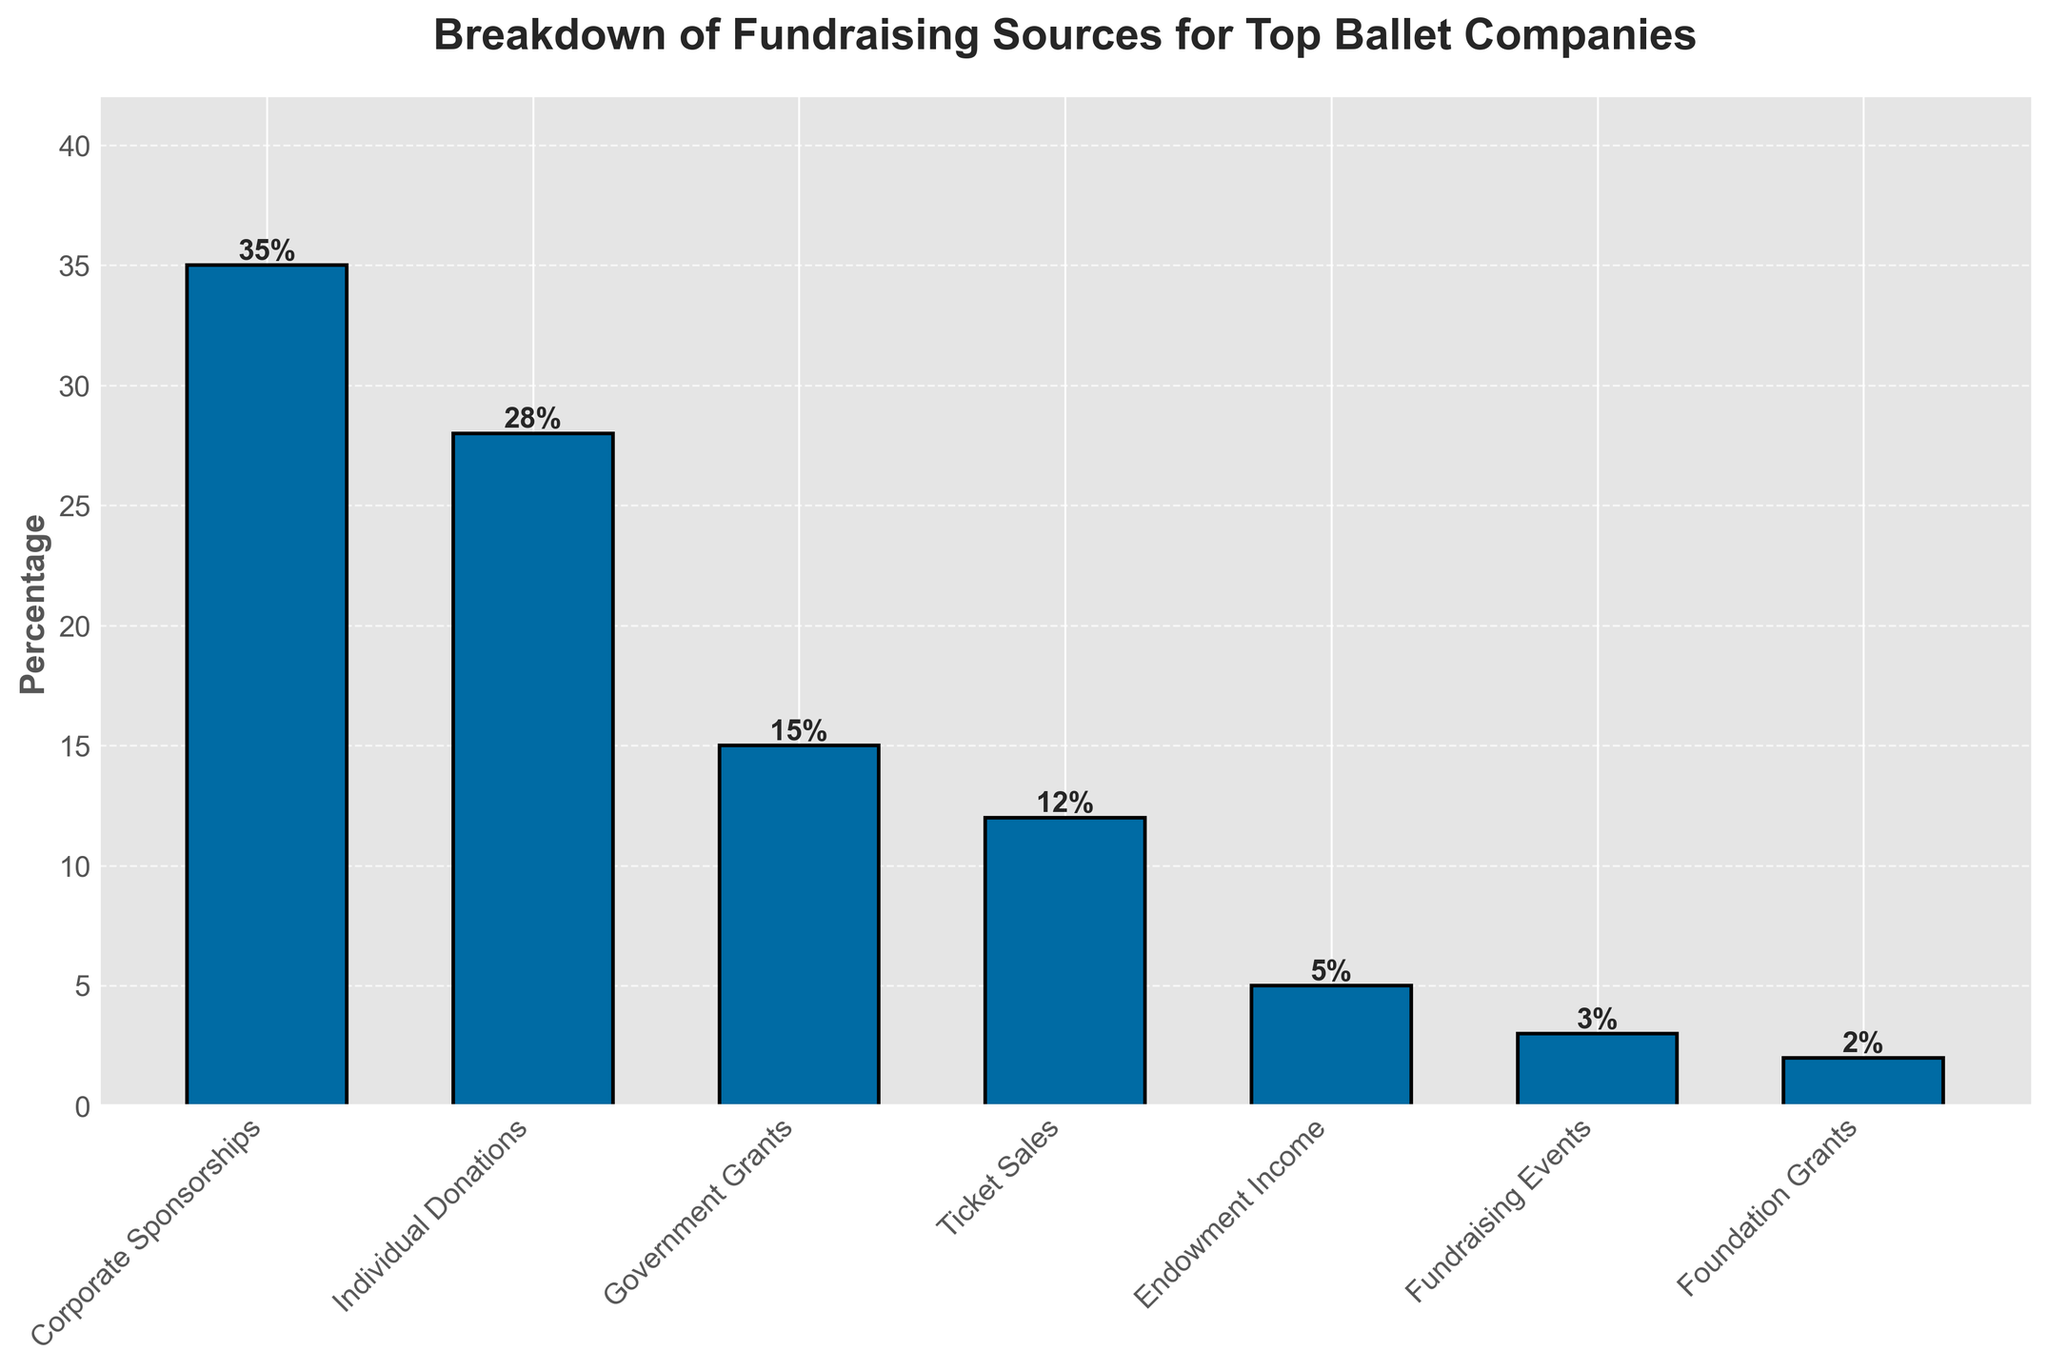What is the largest source of fundraising for top ballet companies? The bar representing Corporate Sponsorships is the tallest in the bar chart, indicating it has the highest percentage.
Answer: Corporate Sponsorships Which source of fundraising has the smallest contribution? The bar representing Foundation Grants is the shortest in the bar chart, indicating it has the smallest percentage.
Answer: Foundation Grants What is the combined percentage of Ticket Sales and Individual Donations? Ticket Sales have a percentage of 12, and Individual Donations have a percentage of 28. Adding these together gives 12 + 28 = 40.
Answer: 40 How much more is raised from Corporate Sponsorships compared with Government Grants? Corporate Sponsorships have a percentage of 35, and Government Grants have a percentage of 15. The difference is 35 - 15 = 20.
Answer: 20 Which two sources of fundraising have the closest percentages? By observing the bar chart, Ticket Sales (12%) and Endowment Income (5%) are the closest among the options available.
Answer: Ticket Sales and Endowment Income Are Individual Donations greater than Government Grants and Ticket Sales combined? Individual Donations have a percentage of 28. The combined percentage of Government Grants (15) and Ticket Sales (12) is 15 + 12 = 27. Since 28 is greater than 27, the answer is yes.
Answer: Yes If the percentage of Corporate Sponsorships increased by 5%, what would be the new percentage? The current percentage for Corporate Sponsorships is 35. Adding 5% to this, the new percentage would be 35 + 5 = 40.
Answer: 40 Rank the top three sources of fundraising in descending order. By observing the heights of the bars, the highest three are Corporate Sponsorships (35%), Individual Donations (28%), and Government Grants (15%) in that order.
Answer: Corporate Sponsorships, Individual Donations, Government Grants What is the average percentage of the three smallest sources of fundraising? The three smallest sources are Foundation Grants (2%), Fundraising Events (3%), and Endowment Income (5%). Adding these together gives 2 + 3 + 5 = 10, and their average is 10 / 3 ≈ 3.33.
Answer: 3.33 